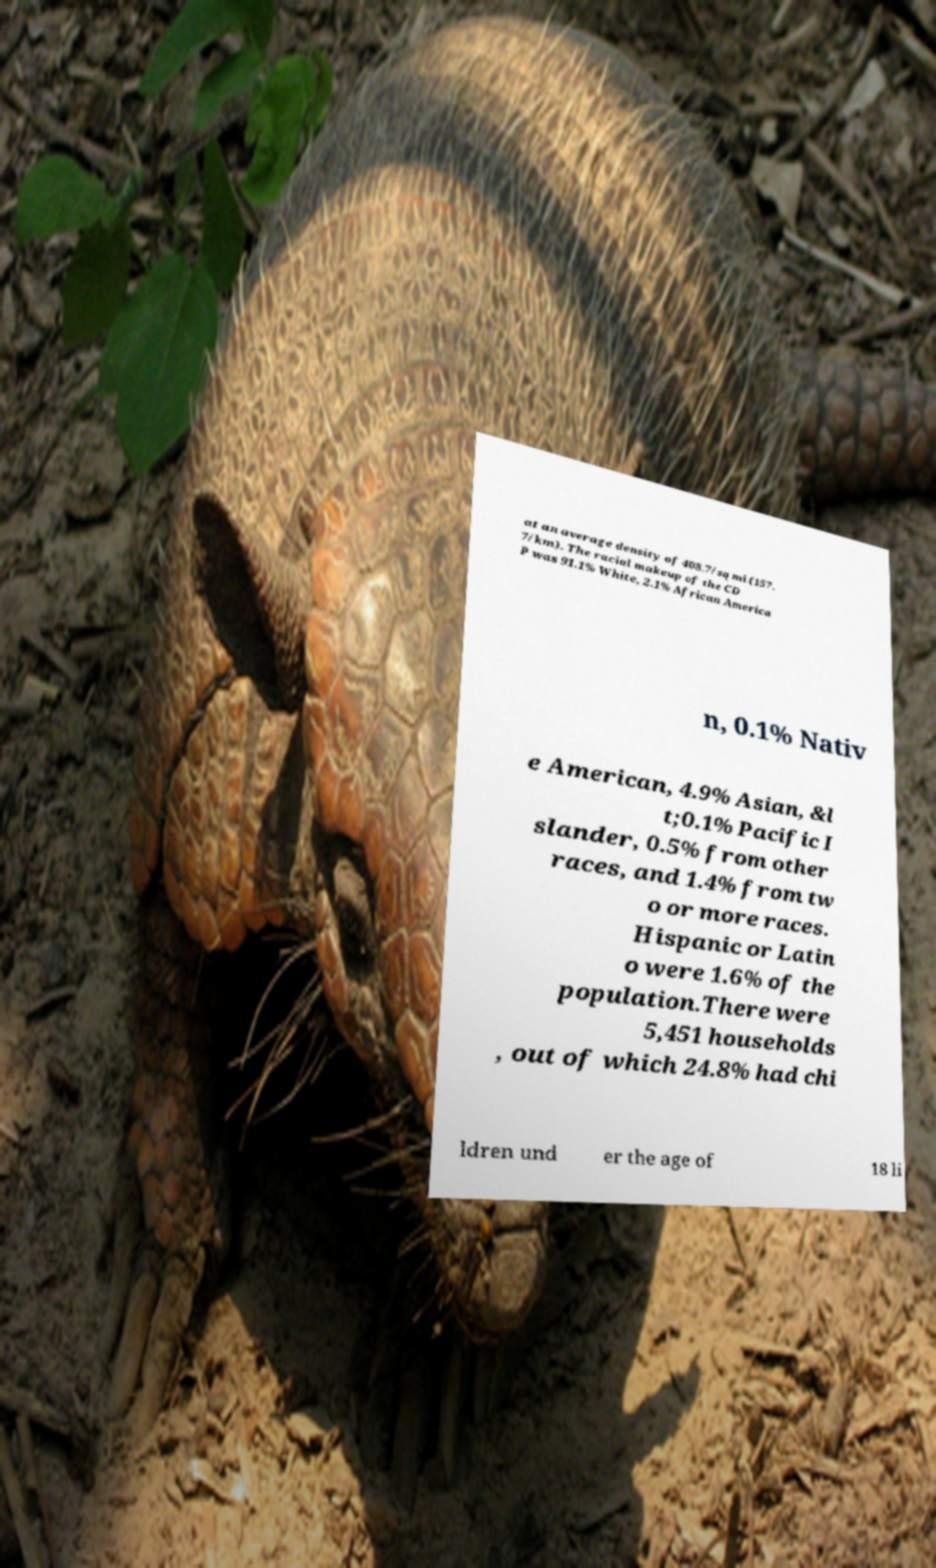Please identify and transcribe the text found in this image. at an average density of 408.7/sq mi (157. 7/km). The racial makeup of the CD P was 91.1% White, 2.1% African America n, 0.1% Nativ e American, 4.9% Asian, &l t;0.1% Pacific I slander, 0.5% from other races, and 1.4% from tw o or more races. Hispanic or Latin o were 1.6% of the population.There were 5,451 households , out of which 24.8% had chi ldren und er the age of 18 li 